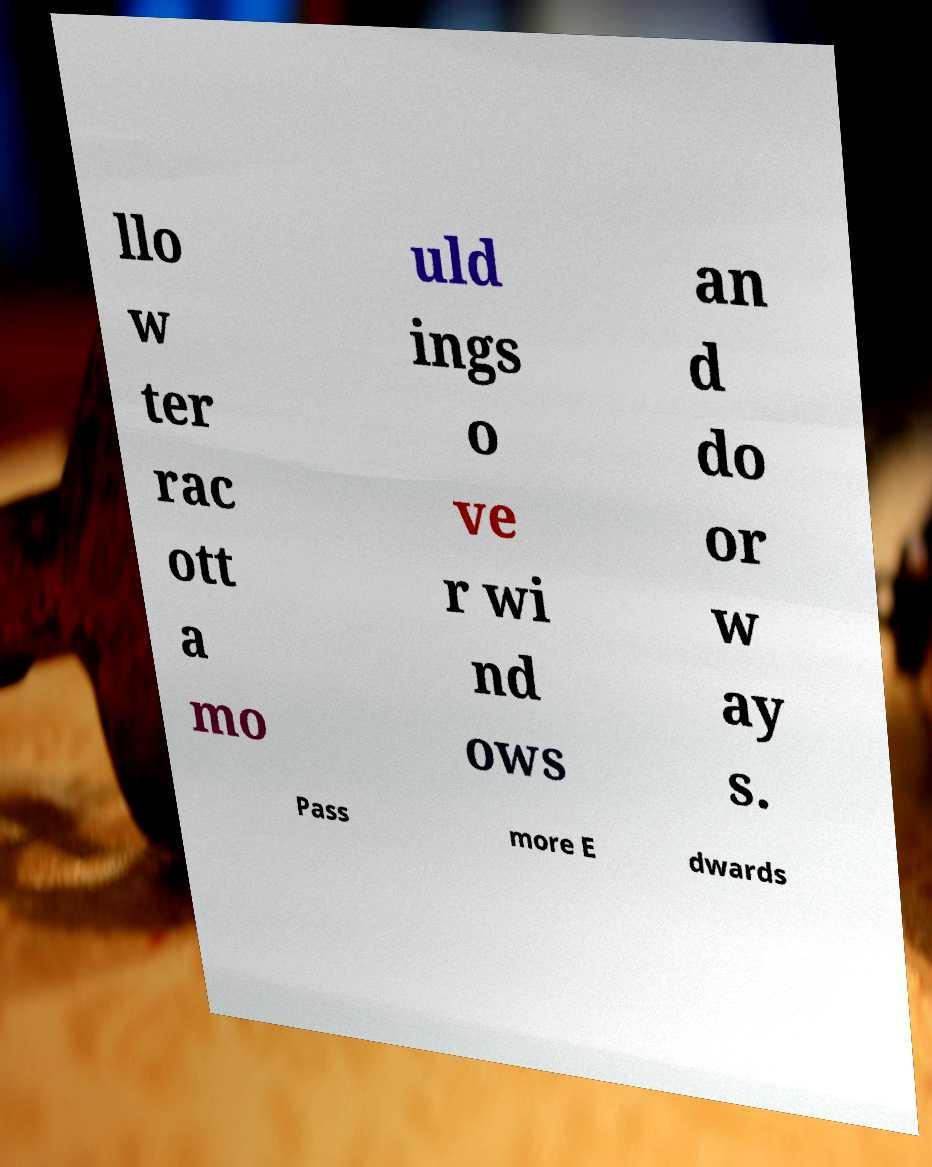Could you extract and type out the text from this image? llo w ter rac ott a mo uld ings o ve r wi nd ows an d do or w ay s. Pass more E dwards 